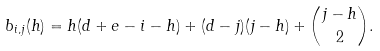Convert formula to latex. <formula><loc_0><loc_0><loc_500><loc_500>b _ { i , j } ( h ) = h ( d + e - i - h ) + ( d - j ) ( j - h ) + \binom { j - h } { 2 } .</formula> 